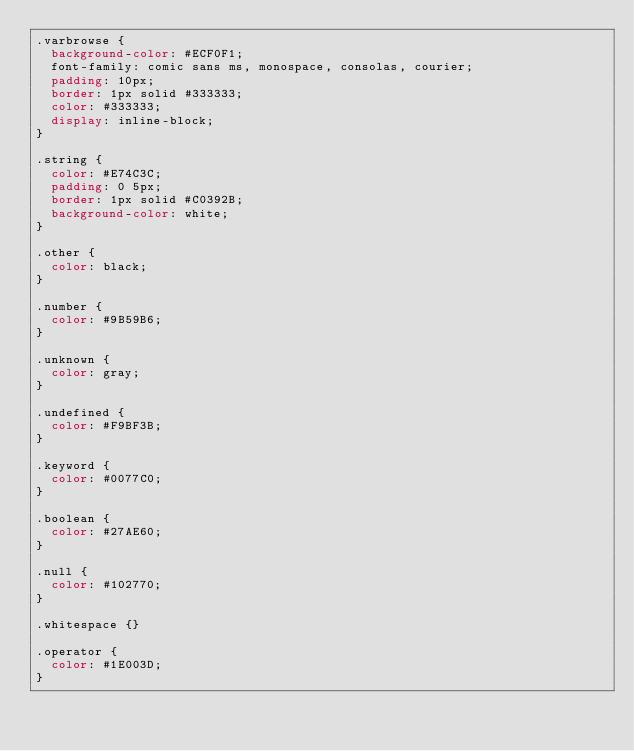<code> <loc_0><loc_0><loc_500><loc_500><_CSS_>.varbrowse {
  background-color: #ECF0F1;
  font-family: comic sans ms, monospace, consolas, courier;
  padding: 10px;
  border: 1px solid #333333;
  color: #333333;
  display: inline-block;
}

.string {
  color: #E74C3C;
  padding: 0 5px;
  border: 1px solid #C0392B;
  background-color: white;
}

.other {
  color: black;
}

.number {
  color: #9B59B6;
}

.unknown {
  color: gray;
}

.undefined {
  color: #F9BF3B;
}

.keyword {
  color: #0077C0;
}

.boolean {
  color: #27AE60;
}

.null {
  color: #102770;
}

.whitespace {}

.operator {
  color: #1E003D;
}</code> 